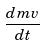Convert formula to latex. <formula><loc_0><loc_0><loc_500><loc_500>\frac { d m v } { d t }</formula> 